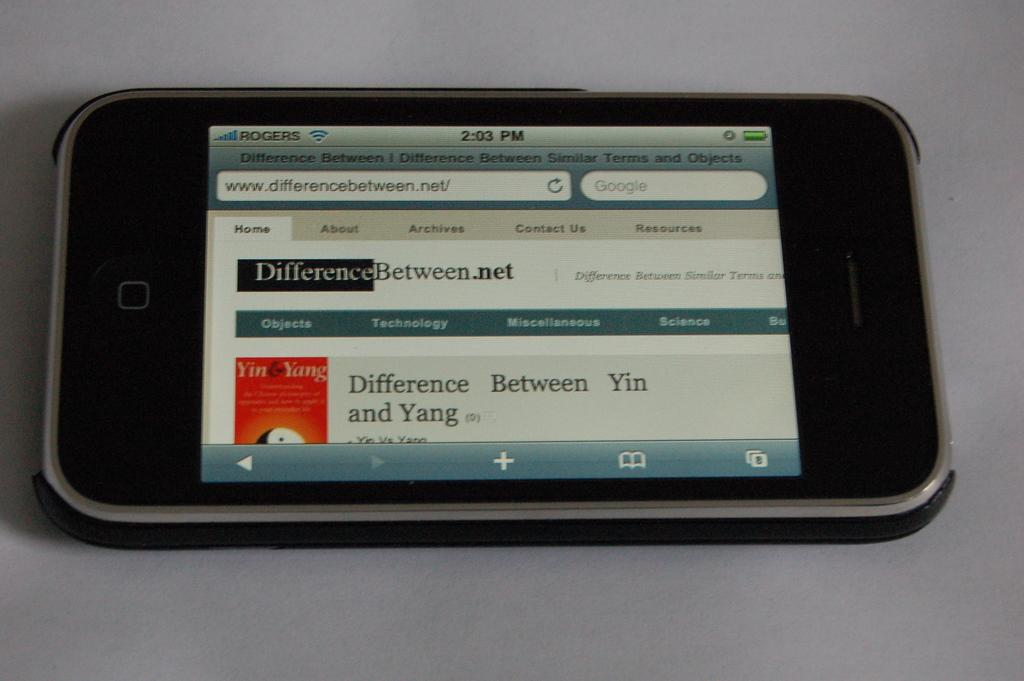Provide a one-sentence caption for the provided image. Iphone is by itself with a website called differencebeween.net. 